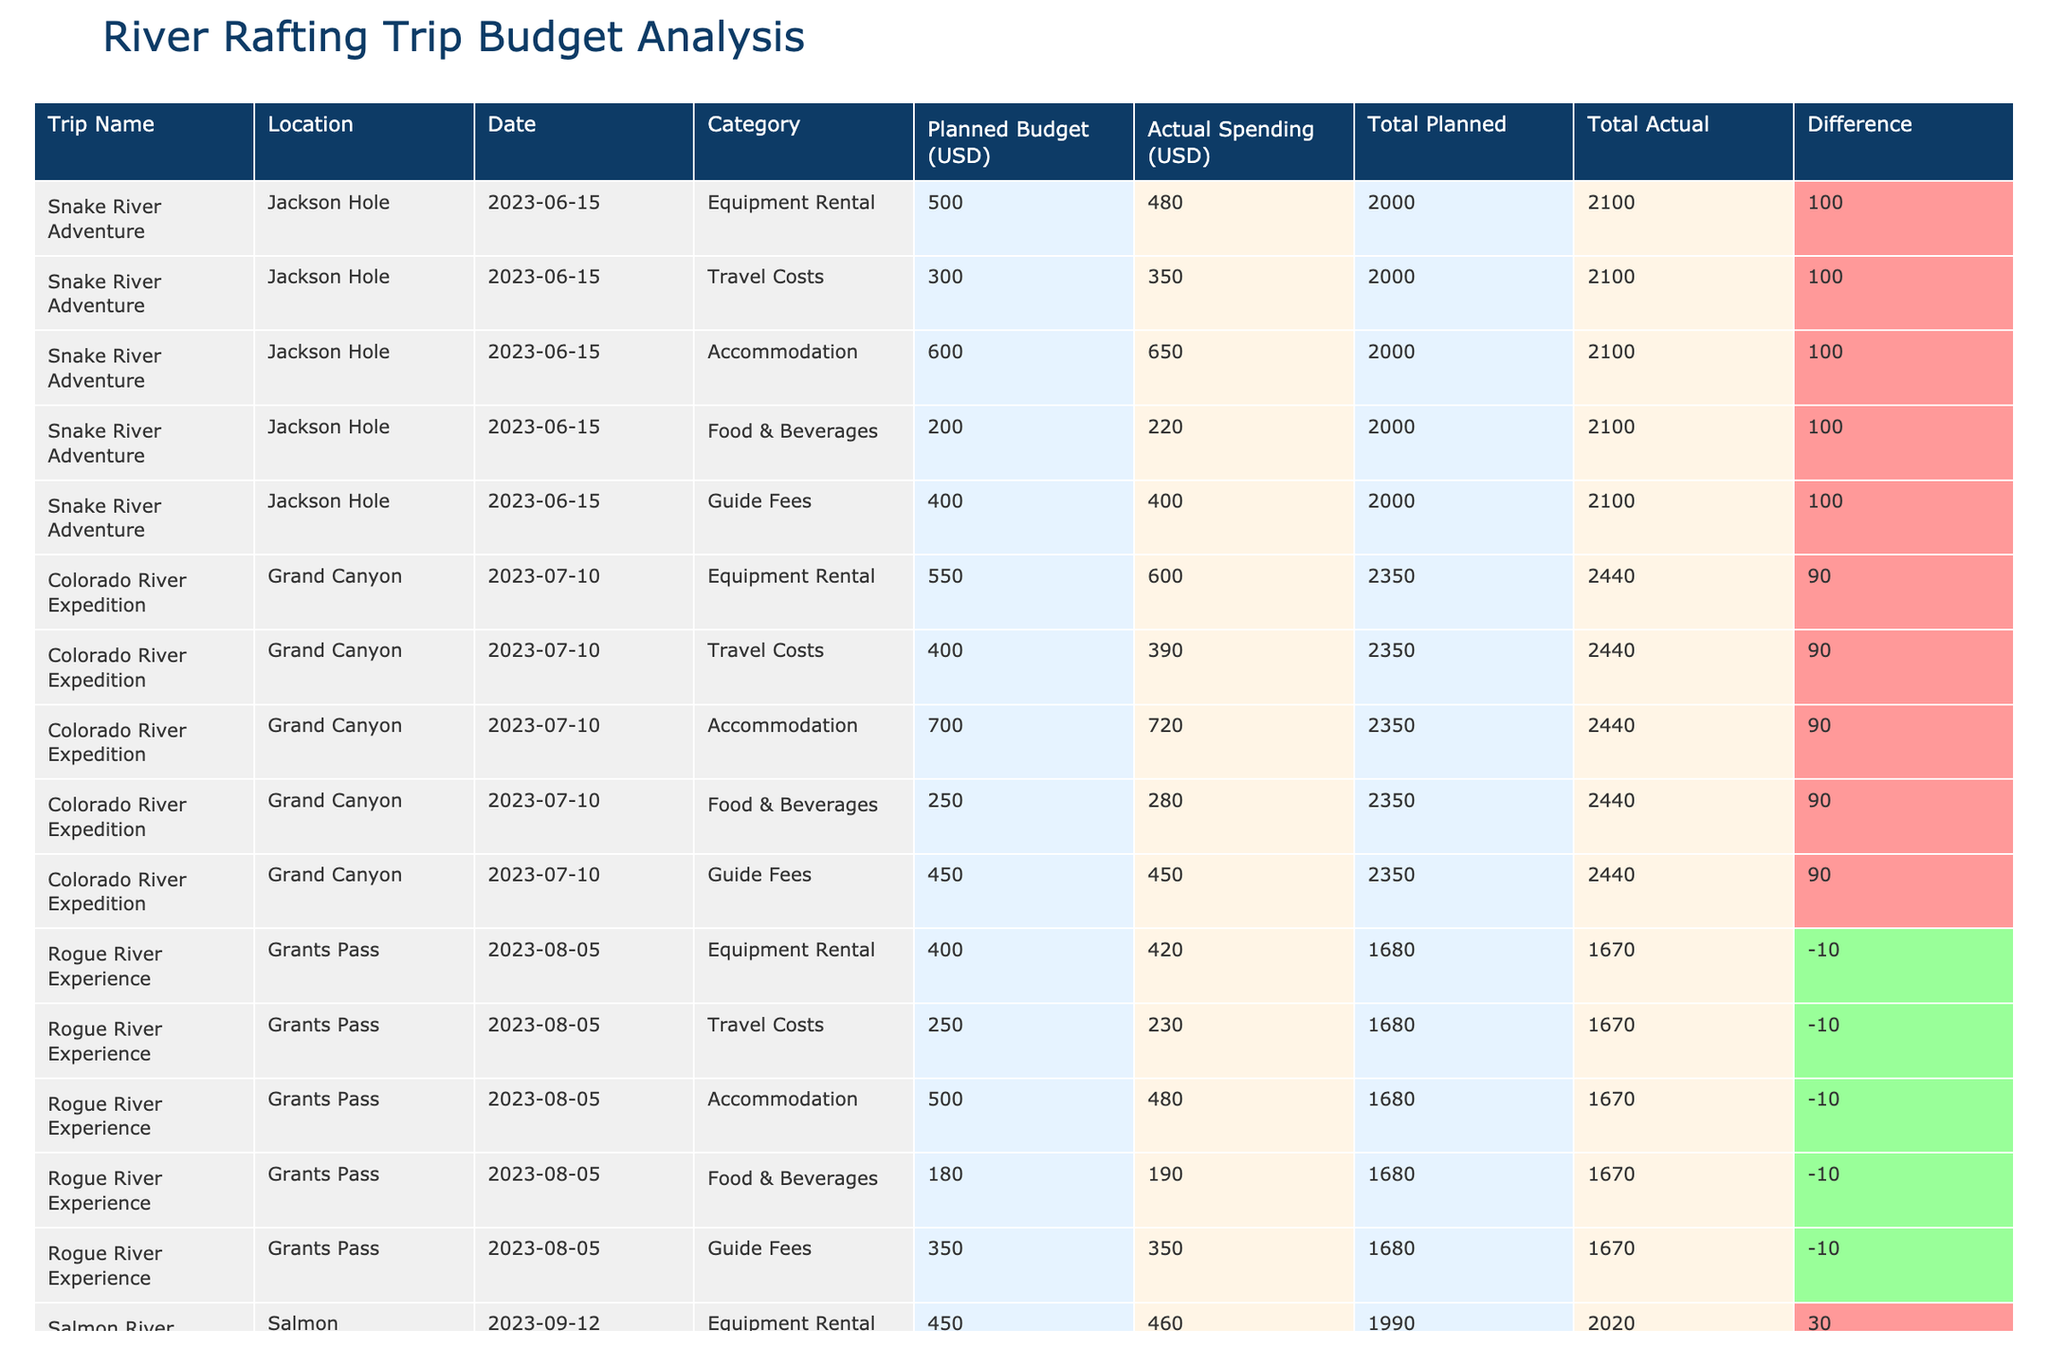What was the planned budget for the Salmon River Journey? The planned budget for the Salmon River Journey can be found in the table under the "Planned Budget (USD)" column for that trip. The value listed is 450.
Answer: 450 Which trip incurred the highest actual spending on accommodation? To find the highest actual spending on accommodation, we compare the "Actual Spending (USD)" values across all trips for the "Accommodation" category. The Colorado River Expedition has the highest spending at 720.
Answer: 720 Was the actual spending for travel costs on the Rogue River Experience lower than planned? We can check the "Travel Costs" category for the Rogue River Experience to see if the actual spending (230) is lower than the planned budget (250). Since 230 is less than 250, the answer is yes.
Answer: Yes What is the combined planned budget for equipment rental across all trips? To find the combined planned budget for equipment rental, we sum the "Planned Budget (USD)" values for the "Equipment Rental" category from all trips: 500 + 550 + 400 + 450 = 1950.
Answer: 1950 Which trip had the largest difference between planned and actual spending? We need to look at the "Difference" column for each trip. Calculating the differences shows that the Colorado River Expedition has the largest difference at 70 (actual is 70 more than planned).
Answer: Colorado River Expedition How much was the total actual spending for the Snake River Adventure? We add up all the actual spending values for the Snake River Adventure from the "Actual Spending (USD)" column. The sum is 480 + 350 + 650 + 220 + 400 = 2100.
Answer: 2100 Did all trips stay within their planned budgets for guide fees? We will check the actual spending for guide fees against the planned budget for each trip. All the trips show actual spending equal to planned budget in this category, meaning yes, all stayed within the budget.
Answer: Yes What was the average actual spending on food & beverages across all trips? To find the average actual spending on food & beverages, we sum the actual values: 220 + 280 + 190 + 240 + 400 = 1320, then divide by the number of trips (5), which gives us an average of 264.
Answer: 264 Which category had the best adherence to the planned budget across the trips? To determine this, we can compare the differences across categories. "Guide Fees" showed no variation (all are 0), while other categories had differences. Hence, Guide Fees had the best adherence.
Answer: Guide Fees 